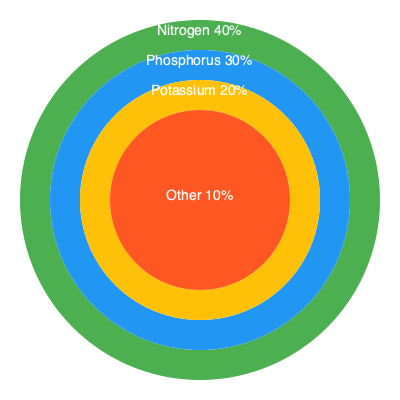Based on the multi-layered pie chart showing soil nutrient composition, calculate the ratio of Nitrogen to Phosphorus to Potassium (N:P:K) in its simplest form. How does this ratio compare to the ideal N:P:K ratio for most crops, which is 4:2:1? What implications might this have for crop growth and soil management in large-scale farming operations? 1. Analyze the nutrient composition:
   - Nitrogen (N): 40%
   - Phosphorus (P): 30%
   - Potassium (K): 20%
   - Other nutrients: 10%

2. Calculate the ratio of N:P:K
   N:P:K = 40:30:20

3. Simplify the ratio:
   Divide all numbers by their greatest common divisor (GCD = 10)
   N:P:K = 4:3:2

4. Compare to the ideal ratio (4:2:1):
   - Nitrogen (N) is at the ideal level
   - Phosphorus (P) is higher than ideal (3 vs 2)
   - Potassium (K) is higher than ideal (2 vs 1)

5. Implications for crop growth and soil management:
   a) The soil has excess Phosphorus and Potassium relative to Nitrogen.
   b) This may lead to:
      - Reduced nitrogen uptake efficiency
      - Potential for phosphorus runoff, causing environmental issues
      - Imbalanced nutrient uptake by plants
   c) Management strategies:
      - Reduce P and K fertilization
      - Increase N application or use nitrogen-fixing cover crops
      - Implement precision agriculture techniques to optimize nutrient distribution
      - Monitor soil pH, as it affects nutrient availability
   d) Long-term considerations:
      - Regular soil testing to track nutrient levels
      - Crop rotation to balance nutrient demands
      - Use of slow-release fertilizers to maintain optimal ratios over time
Answer: N:P:K ratio is 4:3:2; excess P and K relative to N may reduce N uptake efficiency, increase P runoff risk, and cause imbalanced plant nutrition, requiring adjusted fertilization strategies and precision agriculture techniques. 